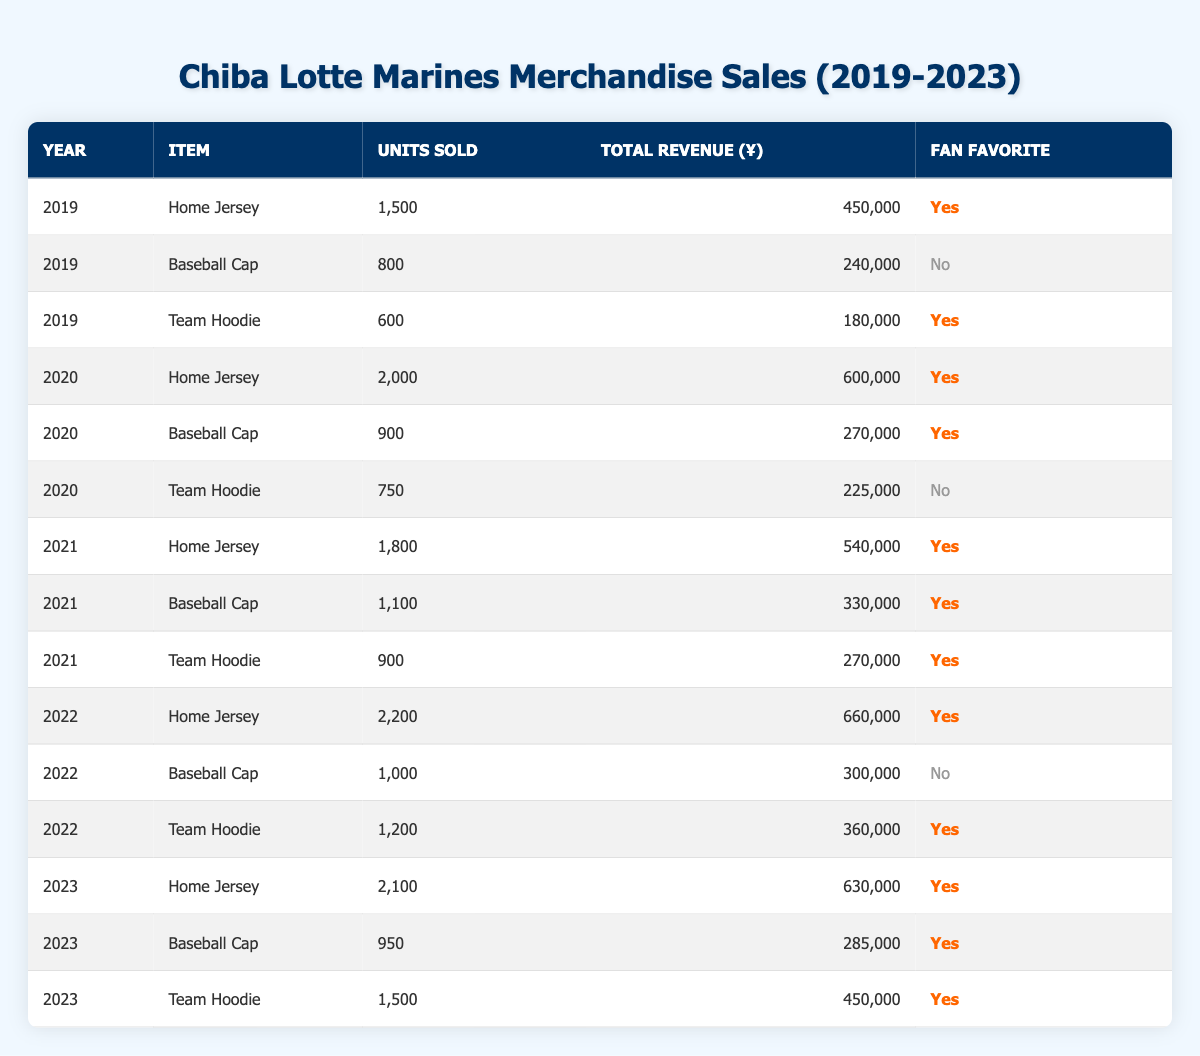What was the total revenue from Home Jerseys sold in 2022? To find this, we look at the row for the year 2022 and the item "Home Jersey." The total revenue for that row is 660,000.
Answer: 660,000 How many Baseball Caps were sold across all years? We need to sum the units sold for "Baseball Cap" from all years: 800 (2019) + 900 (2020) + 1100 (2021) + 1000 (2022) + 950 (2023) = 4750.
Answer: 4750 In which year did the Team Hoodie achieve its highest sales? Looking at the "Team Hoodie" rows, we see the units sold: 600 (2019), 750 (2020), 900 (2021), 1200 (2022), and 1500 (2023). The highest sales occurred in 2023 with 1500 units sold.
Answer: 2023 Was the Baseball Cap a fan favorite in 2021? Checking the row for 2021 and "Baseball Cap," it indicates that it was a fan favorite (Yes).
Answer: Yes What is the average number of Team Hoodies sold per year? We add the units sold for "Team Hoodie": 600 (2019) + 750 (2020) + 900 (2021) + 1200 (2022) + 1500 (2023) = 3960. There are 5 years, so the average is 3960 / 5 = 792.
Answer: 792 Did the total revenue from merchandise sales increase every year from 2019 to 2023? We check the total revenues: 2019 had 450,000, 2020 had 600,000, 2021 had 540,000, 2022 had 660,000, and 2023 had 630,000. There was a decrease from 2020 to 2021, thus the revenue did not increase every year.
Answer: No Which item had the highest units sold in 2020? In 2020, the units sold were: Home Jersey (2000), Baseball Cap (900), and Team Hoodie (750). The highest was the Home Jersey with 2000 units sold.
Answer: Home Jersey How much total revenue was generated from all merchandise sales in 2023? We sum the total revenue for all entries in 2023: 630,000 (Home Jersey) + 285,000 (Baseball Cap) + 450,000 (Team Hoodie) = 1,365,000.
Answer: 1,365,000 Which year had the greatest number of fan favorite items? We analyze each year for fan favorites: 2019 (2), 2020 (2), 2021 (3), 2022 (2), and 2023 (3). The years 2021 and 2023 had the greatest number of fan favorite items, both with 3.
Answer: 2021 and 2023 